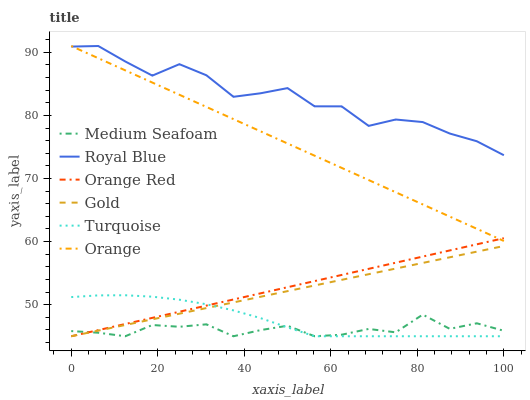Does Medium Seafoam have the minimum area under the curve?
Answer yes or no. Yes. Does Royal Blue have the maximum area under the curve?
Answer yes or no. Yes. Does Gold have the minimum area under the curve?
Answer yes or no. No. Does Gold have the maximum area under the curve?
Answer yes or no. No. Is Gold the smoothest?
Answer yes or no. Yes. Is Royal Blue the roughest?
Answer yes or no. Yes. Is Orange Red the smoothest?
Answer yes or no. No. Is Orange Red the roughest?
Answer yes or no. No. Does Turquoise have the lowest value?
Answer yes or no. Yes. Does Royal Blue have the lowest value?
Answer yes or no. No. Does Orange have the highest value?
Answer yes or no. Yes. Does Gold have the highest value?
Answer yes or no. No. Is Gold less than Royal Blue?
Answer yes or no. Yes. Is Orange greater than Gold?
Answer yes or no. Yes. Does Medium Seafoam intersect Orange Red?
Answer yes or no. Yes. Is Medium Seafoam less than Orange Red?
Answer yes or no. No. Is Medium Seafoam greater than Orange Red?
Answer yes or no. No. Does Gold intersect Royal Blue?
Answer yes or no. No. 